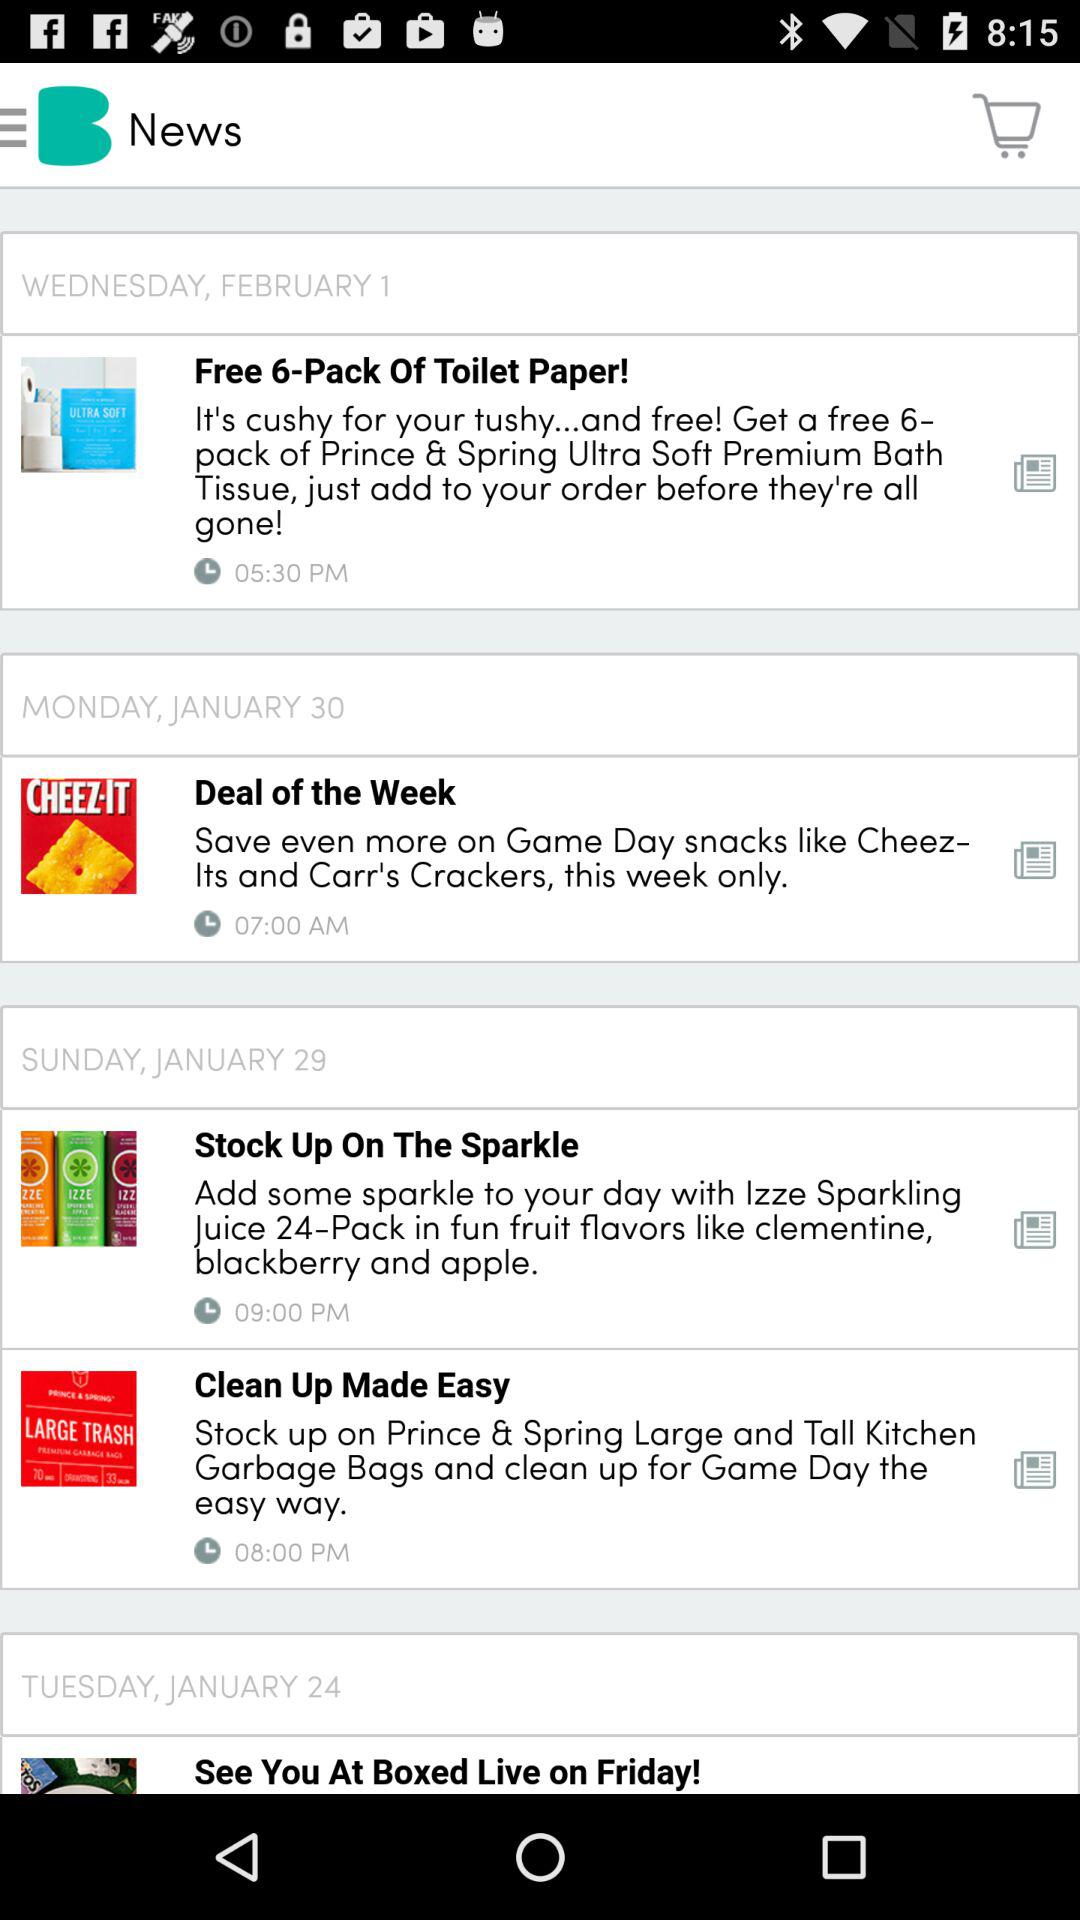When was the news "Deal of the week" published? The news was published on Monday, January 30. 